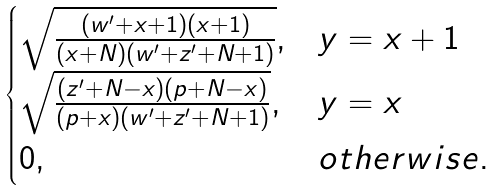<formula> <loc_0><loc_0><loc_500><loc_500>\begin{cases} \sqrt { \frac { ( w ^ { \prime } + x + 1 ) ( x + 1 ) } { ( x + N ) ( w ^ { \prime } + z ^ { \prime } + N + 1 ) } } , & y = x + 1 \\ \sqrt { \frac { ( z ^ { \prime } + N - x ) ( p + N - x ) } { ( p + x ) ( w ^ { \prime } + z ^ { \prime } + N + 1 ) } } , & y = x \\ 0 , & o t h e r w i s e . \end{cases}</formula> 